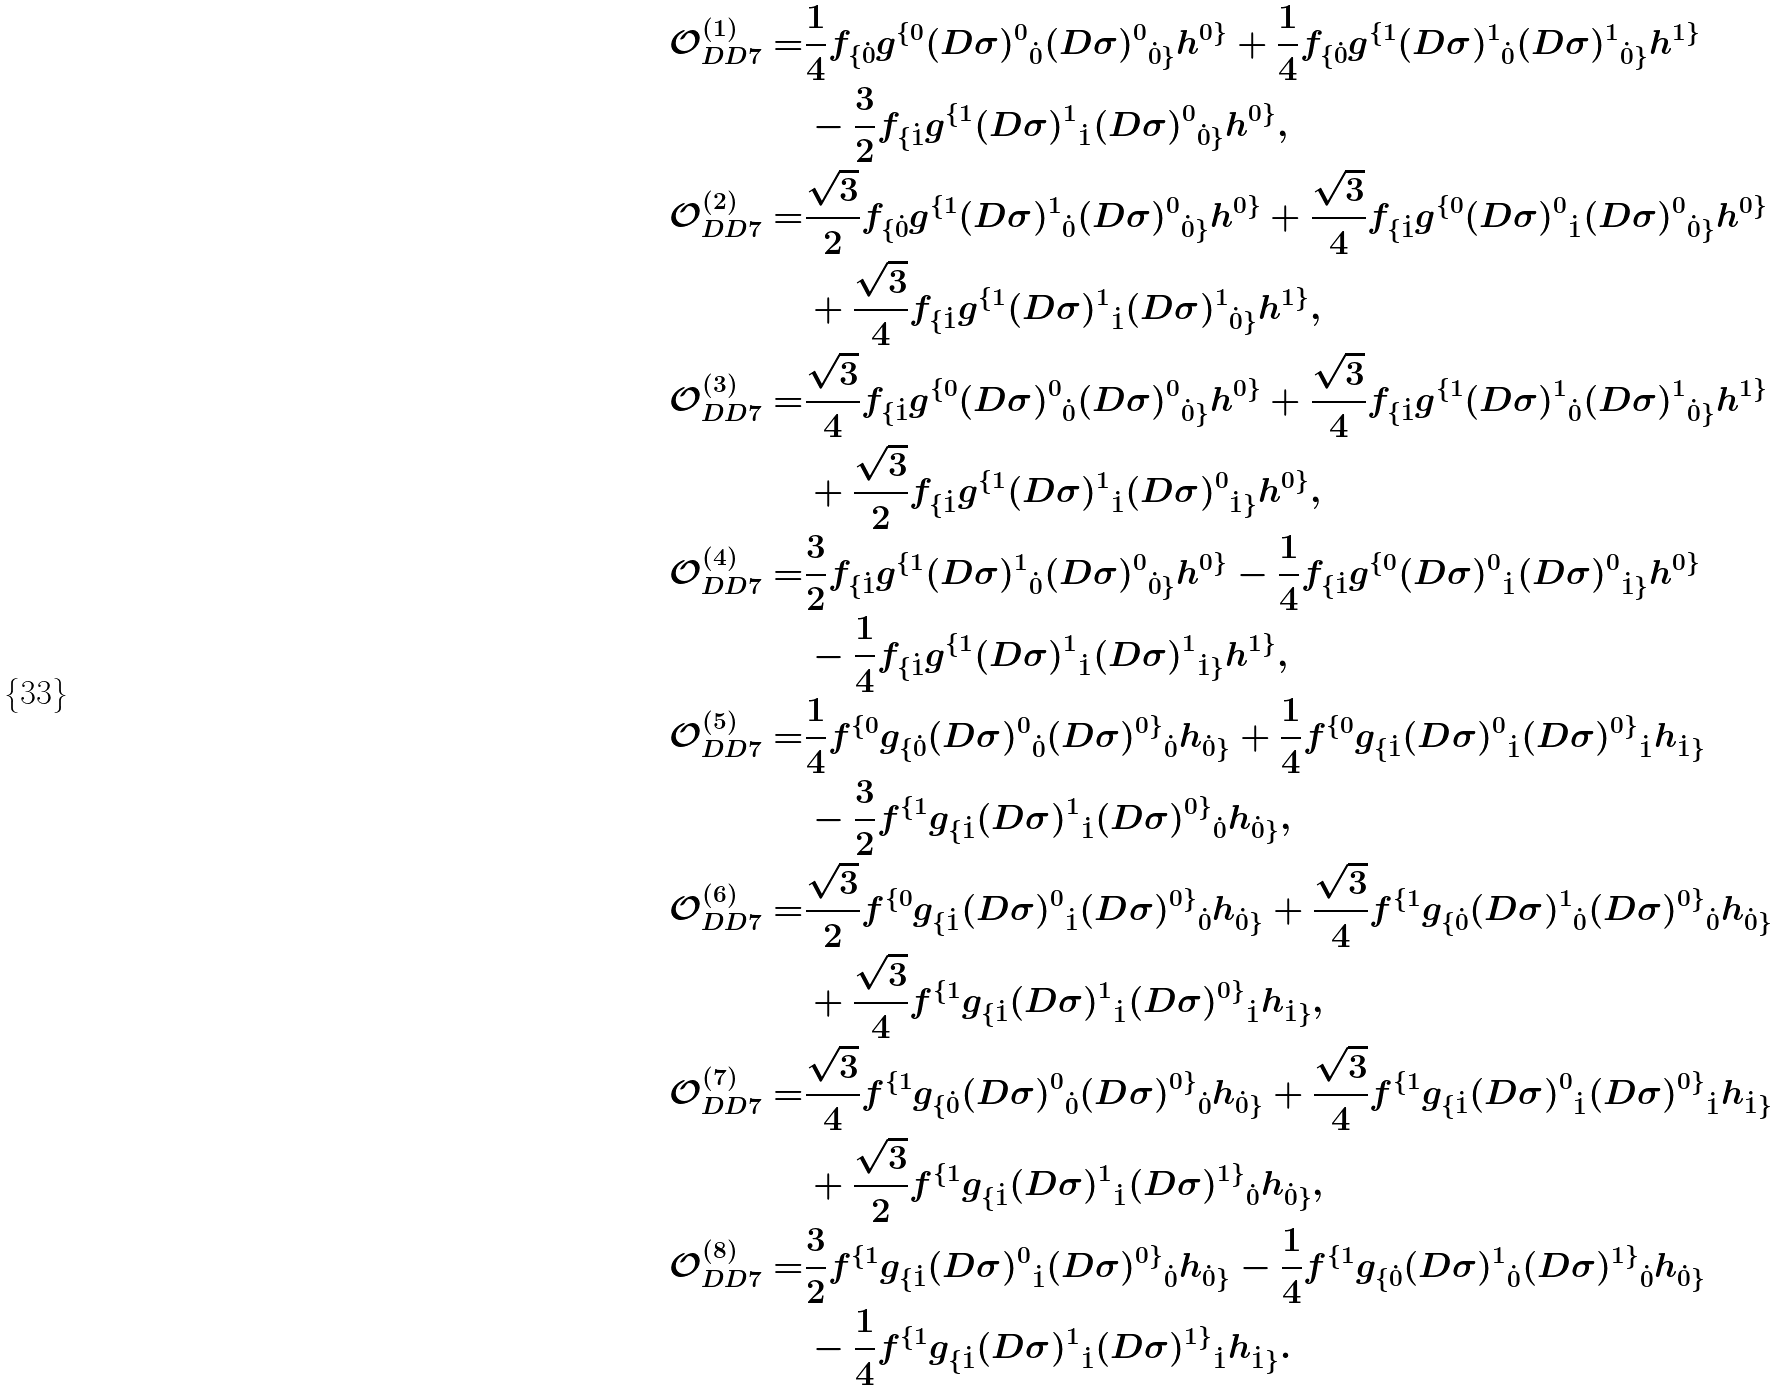Convert formula to latex. <formula><loc_0><loc_0><loc_500><loc_500>\mathcal { O } _ { D D 7 } ^ { ( 1 ) } = & \frac { 1 } { 4 } f _ { \{ \dot { 0 } } g ^ { \{ 0 } { ( D \sigma ) ^ { 0 } } _ { \dot { 0 } } { ( D \sigma ) ^ { 0 } } _ { \dot { 0 } \} } h ^ { 0 \} } + \frac { 1 } { 4 } f _ { \{ \dot { 0 } } g ^ { \{ 1 } { ( D \sigma ) ^ { 1 } } _ { \dot { 0 } } { ( D \sigma ) ^ { 1 } } _ { \dot { 0 } \} } h ^ { 1 \} } \\ & - \frac { 3 } { 2 } f _ { \{ \dot { 1 } } g ^ { \{ 1 } { ( D \sigma ) ^ { 1 } } _ { \dot { 1 } } { ( D \sigma ) ^ { 0 } } _ { \dot { 0 } \} } h ^ { 0 \} } , \\ \mathcal { O } _ { D D 7 } ^ { ( 2 ) } = & \frac { \sqrt { 3 } } { 2 } f _ { \{ \dot { 0 } } g ^ { \{ 1 } { ( D \sigma ) ^ { 1 } } _ { \dot { 0 } } { ( D \sigma ) ^ { 0 } } _ { \dot { 0 } \} } h ^ { 0 \} } + \frac { \sqrt { 3 } } { 4 } f _ { \{ \dot { 1 } } g ^ { \{ 0 } { ( D \sigma ) ^ { 0 } } _ { \dot { 1 } } { ( D \sigma ) ^ { 0 } } _ { \dot { 0 } \} } h ^ { 0 \} } \\ & + \frac { \sqrt { 3 } } { 4 } f _ { \{ \dot { 1 } } g ^ { \{ 1 } { ( D \sigma ) ^ { 1 } } _ { \dot { 1 } } { ( D \sigma ) ^ { 1 } } _ { \dot { 0 } \} } h ^ { 1 \} } , \\ \mathcal { O } _ { D D 7 } ^ { ( 3 ) } = & \frac { \sqrt { 3 } } { 4 } f _ { \{ \dot { 1 } } g ^ { \{ 0 } { ( D \sigma ) ^ { 0 } } _ { \dot { 0 } } { ( D \sigma ) ^ { 0 } } _ { \dot { 0 } \} } h ^ { 0 \} } + \frac { \sqrt { 3 } } { 4 } f _ { \{ \dot { 1 } } g ^ { \{ 1 } { ( D \sigma ) ^ { 1 } } _ { \dot { 0 } } { ( D \sigma ) ^ { 1 } } _ { \dot { 0 } \} } h ^ { 1 \} } \\ & + \frac { \sqrt { 3 } } { 2 } f _ { \{ \dot { 1 } } g ^ { \{ 1 } { ( D \sigma ) ^ { 1 } } _ { \dot { 1 } } { ( D \sigma ) ^ { 0 } } _ { \dot { 1 } \} } h ^ { 0 \} } , \\ \mathcal { O } _ { D D 7 } ^ { ( 4 ) } = & \frac { 3 } { 2 } f _ { \{ \dot { 1 } } g ^ { \{ 1 } { ( D \sigma ) ^ { 1 } } _ { \dot { 0 } } { ( D \sigma ) ^ { 0 } } _ { \dot { 0 } \} } h ^ { 0 \} } - \frac { 1 } { 4 } f _ { \{ \dot { 1 } } g ^ { \{ 0 } { ( D \sigma ) ^ { 0 } } _ { \dot { 1 } } { ( D \sigma ) ^ { 0 } } _ { \dot { 1 } \} } h ^ { 0 \} } \\ & - \frac { 1 } { 4 } f _ { \{ \dot { 1 } } g ^ { \{ 1 } { ( D \sigma ) ^ { 1 } } _ { \dot { 1 } } { ( D \sigma ) ^ { 1 } } _ { \dot { 1 } \} } h ^ { 1 \} } , \\ \mathcal { O } _ { D D 7 } ^ { ( 5 ) } = & \frac { 1 } { 4 } f ^ { \{ 0 } g _ { \{ \dot { 0 } } { ( D \sigma ) ^ { 0 } } _ { \dot { 0 } } { ( D \sigma ) ^ { 0 \} } } _ { \dot { 0 } } h _ { \dot { 0 } \} } + \frac { 1 } { 4 } f ^ { \{ 0 } g _ { \{ \dot { 1 } } { ( D \sigma ) ^ { 0 } } _ { \dot { 1 } } { ( D \sigma ) ^ { 0 \} } } _ { \dot { 1 } } h _ { \dot { 1 } \} } \\ & - \frac { 3 } { 2 } f ^ { \{ 1 } g _ { \{ \dot { 1 } } { ( D \sigma ) ^ { 1 } } _ { \dot { 1 } } { ( D \sigma ) ^ { 0 \} } } _ { \dot { 0 } } h _ { \dot { 0 } \} } , \\ \mathcal { O } _ { D D 7 } ^ { ( 6 ) } = & \frac { \sqrt { 3 } } { 2 } f ^ { \{ 0 } g _ { \{ \dot { 1 } } { ( D \sigma ) ^ { 0 } } _ { \dot { 1 } } { ( D \sigma ) ^ { 0 \} } } _ { \dot { 0 } } h _ { \dot { 0 } \} } + \frac { \sqrt { 3 } } { 4 } f ^ { \{ 1 } g _ { \{ \dot { 0 } } { ( D \sigma ) ^ { 1 } } _ { \dot { 0 } } { ( D \sigma ) ^ { 0 \} } } _ { \dot { 0 } } h _ { \dot { 0 } \} } \\ & + \frac { \sqrt { 3 } } { 4 } f ^ { \{ 1 } g _ { \{ \dot { 1 } } { ( D \sigma ) ^ { 1 } } _ { \dot { 1 } } { ( D \sigma ) ^ { 0 \} } } _ { \dot { 1 } } h _ { \dot { 1 } \} } , \\ \mathcal { O } _ { D D 7 } ^ { ( 7 ) } = & \frac { \sqrt { 3 } } { 4 } f ^ { \{ 1 } g _ { \{ \dot { 0 } } { ( D \sigma ) ^ { 0 } } _ { \dot { 0 } } { ( D \sigma ) ^ { 0 \} } } _ { \dot { 0 } } h _ { \dot { 0 } \} } + \frac { \sqrt { 3 } } { 4 } f ^ { \{ 1 } g _ { \{ \dot { 1 } } { ( D \sigma ) ^ { 0 } } _ { \dot { 1 } } { ( D \sigma ) ^ { 0 \} } } _ { \dot { 1 } } h _ { \dot { 1 } \} } \\ & + \frac { \sqrt { 3 } } { 2 } f ^ { \{ 1 } g _ { \{ \dot { 1 } } { ( D \sigma ) ^ { 1 } } _ { \dot { 1 } } { ( D \sigma ) ^ { 1 \} } } _ { \dot { 0 } } h _ { \dot { 0 } \} } , \\ \mathcal { O } _ { D D 7 } ^ { ( 8 ) } = & \frac { 3 } { 2 } f ^ { \{ 1 } g _ { \{ \dot { 1 } } { ( D \sigma ) ^ { 0 } } _ { \dot { 1 } } { ( D \sigma ) ^ { 0 \} } } _ { \dot { 0 } } h _ { \dot { 0 } \} } - \frac { 1 } { 4 } f ^ { \{ 1 } g _ { \{ \dot { 0 } } { ( D \sigma ) ^ { 1 } } _ { \dot { 0 } } { ( D \sigma ) ^ { 1 \} } } _ { \dot { 0 } } h _ { \dot { 0 } \} } \\ & - \frac { 1 } { 4 } f ^ { \{ 1 } g _ { \{ \dot { 1 } } { ( D \sigma ) ^ { 1 } } _ { \dot { 1 } } { ( D \sigma ) ^ { 1 \} } } _ { \dot { 1 } } h _ { \dot { 1 } \} } .</formula> 